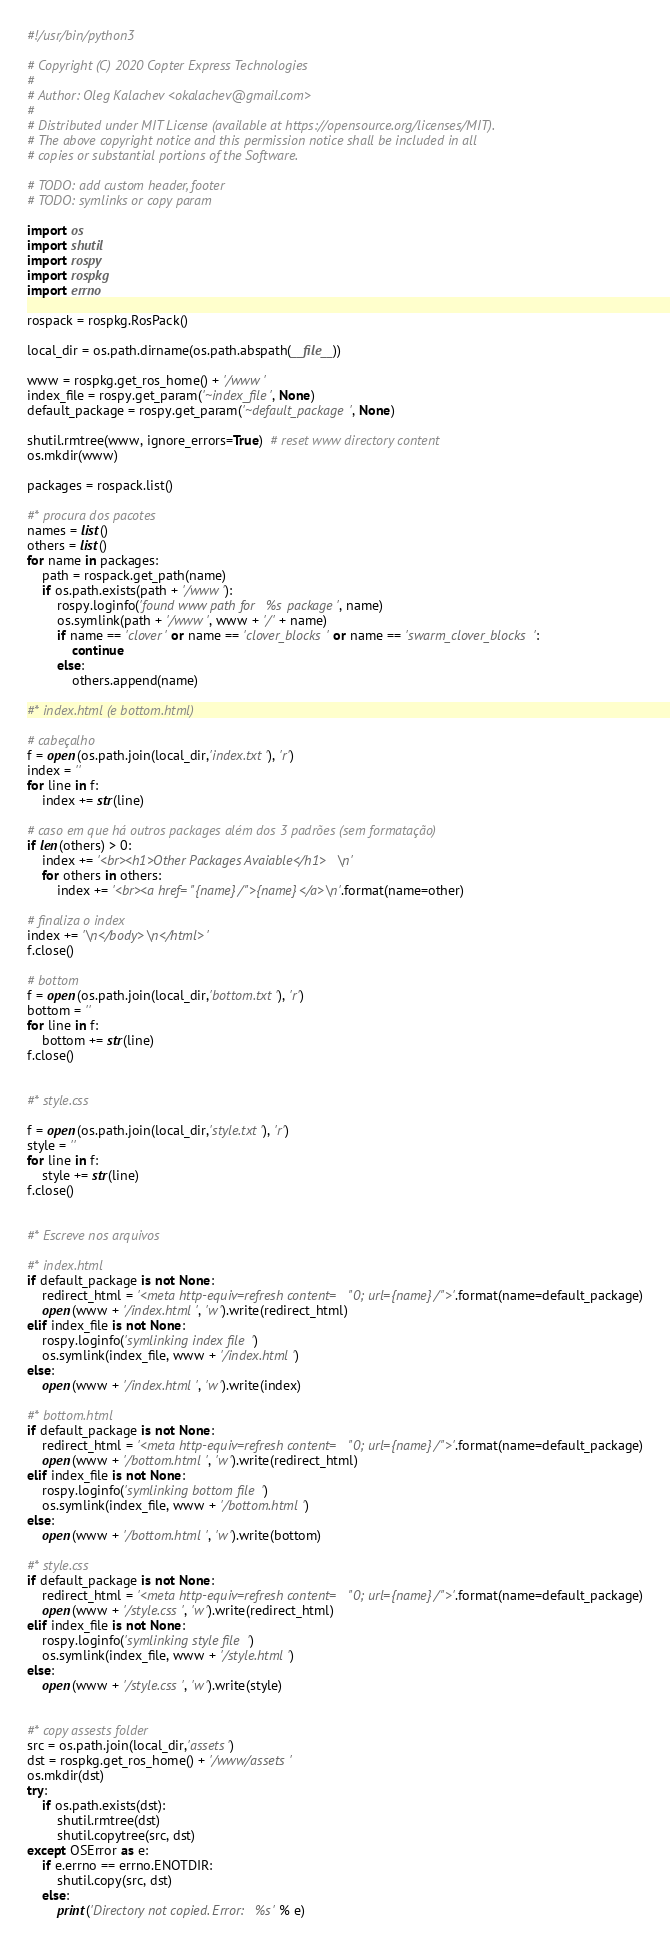<code> <loc_0><loc_0><loc_500><loc_500><_Python_>#!/usr/bin/python3

# Copyright (C) 2020 Copter Express Technologies
#
# Author: Oleg Kalachev <okalachev@gmail.com>
#
# Distributed under MIT License (available at https://opensource.org/licenses/MIT).
# The above copyright notice and this permission notice shall be included in all
# copies or substantial portions of the Software.

# TODO: add custom header, footer
# TODO: symlinks or copy param

import os
import shutil
import rospy
import rospkg
import errno

rospack = rospkg.RosPack()

local_dir = os.path.dirname(os.path.abspath(__file__))

www = rospkg.get_ros_home() + '/www'
index_file = rospy.get_param('~index_file', None)
default_package = rospy.get_param('~default_package', None)

shutil.rmtree(www, ignore_errors=True)  # reset www directory content
os.mkdir(www)

packages = rospack.list()

#* procura dos pacotes
names = list()
others = list()
for name in packages:
    path = rospack.get_path(name)
    if os.path.exists(path + '/www'):
        rospy.loginfo('found www path for %s package', name)
        os.symlink(path + '/www', www + '/' + name)
        if name == 'clover' or name == 'clover_blocks' or name == 'swarm_clover_blocks':
            continue
        else:
            others.append(name)

#* index.html (e bottom.html)

# cabeçalho
f = open(os.path.join(local_dir,'index.txt'), 'r')
index = ''
for line in f:
    index += str(line)

# caso em que há outros packages além dos 3 padrões (sem formatação)
if len(others) > 0:
    index += '<br><h1>Other Packages Avaiable</h1>\n'
    for others in others:
        index += '<br><a href="{name}/">{name}</a>\n'.format(name=other)

# finaliza o index
index += '\n</body>\n</html>'
f.close()

# bottom
f = open(os.path.join(local_dir,'bottom.txt'), 'r')
bottom = ''
for line in f:
    bottom += str(line)
f.close()


#* style.css

f = open(os.path.join(local_dir,'style.txt'), 'r')
style = ''
for line in f:
    style += str(line)
f.close()


#* Escreve nos arquivos 

#* index.html
if default_package is not None:
    redirect_html = '<meta http-equiv=refresh content="0; url={name}/">'.format(name=default_package)
    open(www + '/index.html', 'w').write(redirect_html)
elif index_file is not None:
    rospy.loginfo('symlinking index file')
    os.symlink(index_file, www + '/index.html')
else:
    open(www + '/index.html', 'w').write(index)

#* bottom.html
if default_package is not None:
    redirect_html = '<meta http-equiv=refresh content="0; url={name}/">'.format(name=default_package)
    open(www + '/bottom.html', 'w').write(redirect_html)
elif index_file is not None:
    rospy.loginfo('symlinking bottom file')
    os.symlink(index_file, www + '/bottom.html')
else:
    open(www + '/bottom.html', 'w').write(bottom)

#* style.css
if default_package is not None:
    redirect_html = '<meta http-equiv=refresh content="0; url={name}/">'.format(name=default_package)
    open(www + '/style.css', 'w').write(redirect_html)
elif index_file is not None:
    rospy.loginfo('symlinking style file')
    os.symlink(index_file, www + '/style.html')
else:
    open(www + '/style.css', 'w').write(style)


#* copy assests folder
src = os.path.join(local_dir,'assets')
dst = rospkg.get_ros_home() + '/www/assets'
os.mkdir(dst)
try:
    if os.path.exists(dst):
        shutil.rmtree(dst)
        shutil.copytree(src, dst)
except OSError as e:
    if e.errno == errno.ENOTDIR:
        shutil.copy(src, dst)
    else:
        print('Directory not copied. Error: %s' % e)</code> 